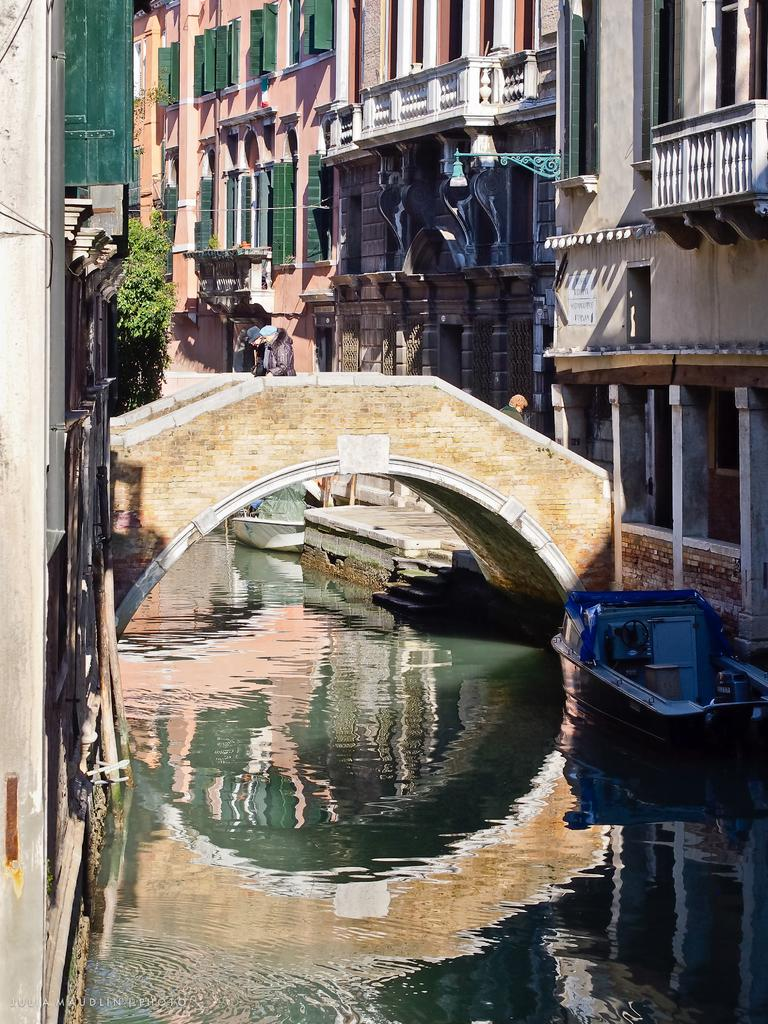What type of structures can be seen in the image? There are buildings in the image. What else can be seen in the image besides buildings? There are plants, windows, a bridge, and a boat on the water in the image. Can you describe the water element in the image? There is a boat on the water in the image. Where is the scarecrow standing in the image? There is no scarecrow present in the image. What type of respect is shown by the plants in the image? There are no plants exhibiting respect in the image, as plants do not have the ability to show respect. 